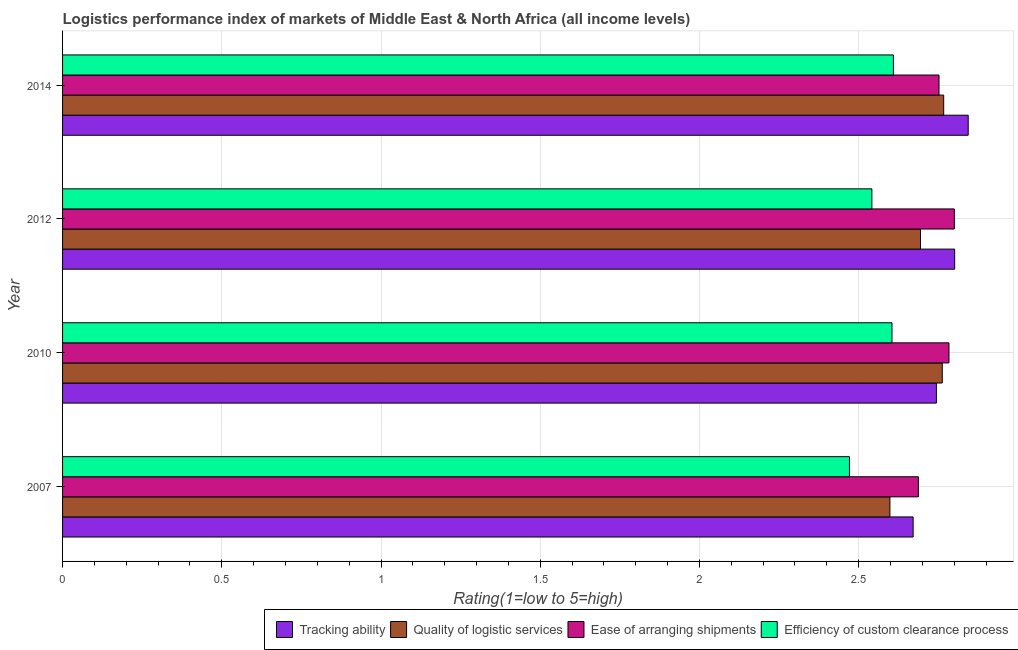How many different coloured bars are there?
Keep it short and to the point. 4. Are the number of bars on each tick of the Y-axis equal?
Ensure brevity in your answer.  Yes. How many bars are there on the 2nd tick from the top?
Your answer should be very brief. 4. What is the label of the 3rd group of bars from the top?
Provide a short and direct response. 2010. What is the lpi rating of efficiency of custom clearance process in 2010?
Offer a very short reply. 2.6. Across all years, what is the maximum lpi rating of tracking ability?
Offer a terse response. 2.84. Across all years, what is the minimum lpi rating of efficiency of custom clearance process?
Your answer should be very brief. 2.47. In which year was the lpi rating of ease of arranging shipments minimum?
Your answer should be compact. 2007. What is the total lpi rating of efficiency of custom clearance process in the graph?
Your response must be concise. 10.23. What is the difference between the lpi rating of quality of logistic services in 2007 and that in 2010?
Make the answer very short. -0.16. What is the difference between the lpi rating of ease of arranging shipments in 2010 and the lpi rating of tracking ability in 2007?
Give a very brief answer. 0.11. What is the average lpi rating of ease of arranging shipments per year?
Make the answer very short. 2.76. In the year 2014, what is the difference between the lpi rating of tracking ability and lpi rating of quality of logistic services?
Your answer should be very brief. 0.08. What is the difference between the highest and the second highest lpi rating of quality of logistic services?
Provide a succinct answer. 0. What is the difference between the highest and the lowest lpi rating of ease of arranging shipments?
Offer a very short reply. 0.11. Is it the case that in every year, the sum of the lpi rating of quality of logistic services and lpi rating of efficiency of custom clearance process is greater than the sum of lpi rating of ease of arranging shipments and lpi rating of tracking ability?
Offer a terse response. No. What does the 3rd bar from the top in 2012 represents?
Your answer should be compact. Quality of logistic services. What does the 3rd bar from the bottom in 2012 represents?
Make the answer very short. Ease of arranging shipments. Is it the case that in every year, the sum of the lpi rating of tracking ability and lpi rating of quality of logistic services is greater than the lpi rating of ease of arranging shipments?
Give a very brief answer. Yes. Are all the bars in the graph horizontal?
Your answer should be compact. Yes. What is the difference between two consecutive major ticks on the X-axis?
Keep it short and to the point. 0.5. Are the values on the major ticks of X-axis written in scientific E-notation?
Your answer should be compact. No. Does the graph contain any zero values?
Ensure brevity in your answer.  No. Does the graph contain grids?
Provide a short and direct response. Yes. How many legend labels are there?
Give a very brief answer. 4. What is the title of the graph?
Your response must be concise. Logistics performance index of markets of Middle East & North Africa (all income levels). Does "Structural Policies" appear as one of the legend labels in the graph?
Make the answer very short. No. What is the label or title of the X-axis?
Your answer should be compact. Rating(1=low to 5=high). What is the Rating(1=low to 5=high) in Tracking ability in 2007?
Offer a terse response. 2.67. What is the Rating(1=low to 5=high) in Quality of logistic services in 2007?
Keep it short and to the point. 2.6. What is the Rating(1=low to 5=high) in Ease of arranging shipments in 2007?
Keep it short and to the point. 2.69. What is the Rating(1=low to 5=high) of Efficiency of custom clearance process in 2007?
Your answer should be compact. 2.47. What is the Rating(1=low to 5=high) in Tracking ability in 2010?
Keep it short and to the point. 2.74. What is the Rating(1=low to 5=high) of Quality of logistic services in 2010?
Your response must be concise. 2.76. What is the Rating(1=low to 5=high) in Ease of arranging shipments in 2010?
Offer a very short reply. 2.78. What is the Rating(1=low to 5=high) of Efficiency of custom clearance process in 2010?
Your response must be concise. 2.6. What is the Rating(1=low to 5=high) in Tracking ability in 2012?
Your answer should be very brief. 2.8. What is the Rating(1=low to 5=high) of Quality of logistic services in 2012?
Make the answer very short. 2.69. What is the Rating(1=low to 5=high) of Ease of arranging shipments in 2012?
Make the answer very short. 2.8. What is the Rating(1=low to 5=high) of Efficiency of custom clearance process in 2012?
Ensure brevity in your answer.  2.54. What is the Rating(1=low to 5=high) of Tracking ability in 2014?
Provide a succinct answer. 2.84. What is the Rating(1=low to 5=high) of Quality of logistic services in 2014?
Provide a short and direct response. 2.77. What is the Rating(1=low to 5=high) of Ease of arranging shipments in 2014?
Your response must be concise. 2.75. What is the Rating(1=low to 5=high) of Efficiency of custom clearance process in 2014?
Ensure brevity in your answer.  2.61. Across all years, what is the maximum Rating(1=low to 5=high) of Tracking ability?
Provide a short and direct response. 2.84. Across all years, what is the maximum Rating(1=low to 5=high) in Quality of logistic services?
Your answer should be very brief. 2.77. Across all years, what is the maximum Rating(1=low to 5=high) in Ease of arranging shipments?
Your answer should be compact. 2.8. Across all years, what is the maximum Rating(1=low to 5=high) in Efficiency of custom clearance process?
Keep it short and to the point. 2.61. Across all years, what is the minimum Rating(1=low to 5=high) of Tracking ability?
Offer a terse response. 2.67. Across all years, what is the minimum Rating(1=low to 5=high) in Quality of logistic services?
Keep it short and to the point. 2.6. Across all years, what is the minimum Rating(1=low to 5=high) of Ease of arranging shipments?
Offer a terse response. 2.69. Across all years, what is the minimum Rating(1=low to 5=high) in Efficiency of custom clearance process?
Provide a succinct answer. 2.47. What is the total Rating(1=low to 5=high) in Tracking ability in the graph?
Your answer should be compact. 11.06. What is the total Rating(1=low to 5=high) in Quality of logistic services in the graph?
Offer a very short reply. 10.82. What is the total Rating(1=low to 5=high) of Ease of arranging shipments in the graph?
Make the answer very short. 11.02. What is the total Rating(1=low to 5=high) in Efficiency of custom clearance process in the graph?
Ensure brevity in your answer.  10.23. What is the difference between the Rating(1=low to 5=high) in Tracking ability in 2007 and that in 2010?
Your response must be concise. -0.07. What is the difference between the Rating(1=low to 5=high) in Quality of logistic services in 2007 and that in 2010?
Give a very brief answer. -0.16. What is the difference between the Rating(1=low to 5=high) in Ease of arranging shipments in 2007 and that in 2010?
Give a very brief answer. -0.1. What is the difference between the Rating(1=low to 5=high) in Efficiency of custom clearance process in 2007 and that in 2010?
Your answer should be compact. -0.13. What is the difference between the Rating(1=low to 5=high) of Tracking ability in 2007 and that in 2012?
Provide a succinct answer. -0.13. What is the difference between the Rating(1=low to 5=high) of Quality of logistic services in 2007 and that in 2012?
Your answer should be very brief. -0.1. What is the difference between the Rating(1=low to 5=high) in Ease of arranging shipments in 2007 and that in 2012?
Your answer should be very brief. -0.11. What is the difference between the Rating(1=low to 5=high) of Efficiency of custom clearance process in 2007 and that in 2012?
Make the answer very short. -0.07. What is the difference between the Rating(1=low to 5=high) of Tracking ability in 2007 and that in 2014?
Provide a succinct answer. -0.17. What is the difference between the Rating(1=low to 5=high) in Quality of logistic services in 2007 and that in 2014?
Your answer should be very brief. -0.17. What is the difference between the Rating(1=low to 5=high) of Ease of arranging shipments in 2007 and that in 2014?
Provide a succinct answer. -0.06. What is the difference between the Rating(1=low to 5=high) of Efficiency of custom clearance process in 2007 and that in 2014?
Ensure brevity in your answer.  -0.14. What is the difference between the Rating(1=low to 5=high) in Tracking ability in 2010 and that in 2012?
Your response must be concise. -0.06. What is the difference between the Rating(1=low to 5=high) of Quality of logistic services in 2010 and that in 2012?
Your answer should be compact. 0.07. What is the difference between the Rating(1=low to 5=high) in Ease of arranging shipments in 2010 and that in 2012?
Keep it short and to the point. -0.02. What is the difference between the Rating(1=low to 5=high) in Efficiency of custom clearance process in 2010 and that in 2012?
Provide a short and direct response. 0.06. What is the difference between the Rating(1=low to 5=high) in Tracking ability in 2010 and that in 2014?
Offer a very short reply. -0.1. What is the difference between the Rating(1=low to 5=high) of Quality of logistic services in 2010 and that in 2014?
Offer a terse response. -0. What is the difference between the Rating(1=low to 5=high) of Ease of arranging shipments in 2010 and that in 2014?
Give a very brief answer. 0.03. What is the difference between the Rating(1=low to 5=high) of Efficiency of custom clearance process in 2010 and that in 2014?
Your response must be concise. -0. What is the difference between the Rating(1=low to 5=high) in Tracking ability in 2012 and that in 2014?
Provide a short and direct response. -0.04. What is the difference between the Rating(1=low to 5=high) of Quality of logistic services in 2012 and that in 2014?
Provide a succinct answer. -0.07. What is the difference between the Rating(1=low to 5=high) in Ease of arranging shipments in 2012 and that in 2014?
Provide a succinct answer. 0.05. What is the difference between the Rating(1=low to 5=high) in Efficiency of custom clearance process in 2012 and that in 2014?
Your response must be concise. -0.07. What is the difference between the Rating(1=low to 5=high) in Tracking ability in 2007 and the Rating(1=low to 5=high) in Quality of logistic services in 2010?
Make the answer very short. -0.09. What is the difference between the Rating(1=low to 5=high) in Tracking ability in 2007 and the Rating(1=low to 5=high) in Ease of arranging shipments in 2010?
Offer a very short reply. -0.11. What is the difference between the Rating(1=low to 5=high) of Tracking ability in 2007 and the Rating(1=low to 5=high) of Efficiency of custom clearance process in 2010?
Keep it short and to the point. 0.07. What is the difference between the Rating(1=low to 5=high) of Quality of logistic services in 2007 and the Rating(1=low to 5=high) of Ease of arranging shipments in 2010?
Provide a short and direct response. -0.19. What is the difference between the Rating(1=low to 5=high) of Quality of logistic services in 2007 and the Rating(1=low to 5=high) of Efficiency of custom clearance process in 2010?
Keep it short and to the point. -0.01. What is the difference between the Rating(1=low to 5=high) of Ease of arranging shipments in 2007 and the Rating(1=low to 5=high) of Efficiency of custom clearance process in 2010?
Keep it short and to the point. 0.08. What is the difference between the Rating(1=low to 5=high) of Tracking ability in 2007 and the Rating(1=low to 5=high) of Quality of logistic services in 2012?
Ensure brevity in your answer.  -0.02. What is the difference between the Rating(1=low to 5=high) in Tracking ability in 2007 and the Rating(1=low to 5=high) in Ease of arranging shipments in 2012?
Your answer should be compact. -0.13. What is the difference between the Rating(1=low to 5=high) of Tracking ability in 2007 and the Rating(1=low to 5=high) of Efficiency of custom clearance process in 2012?
Offer a very short reply. 0.13. What is the difference between the Rating(1=low to 5=high) in Quality of logistic services in 2007 and the Rating(1=low to 5=high) in Ease of arranging shipments in 2012?
Provide a short and direct response. -0.2. What is the difference between the Rating(1=low to 5=high) of Quality of logistic services in 2007 and the Rating(1=low to 5=high) of Efficiency of custom clearance process in 2012?
Provide a succinct answer. 0.06. What is the difference between the Rating(1=low to 5=high) in Ease of arranging shipments in 2007 and the Rating(1=low to 5=high) in Efficiency of custom clearance process in 2012?
Offer a very short reply. 0.15. What is the difference between the Rating(1=low to 5=high) of Tracking ability in 2007 and the Rating(1=low to 5=high) of Quality of logistic services in 2014?
Make the answer very short. -0.1. What is the difference between the Rating(1=low to 5=high) of Tracking ability in 2007 and the Rating(1=low to 5=high) of Ease of arranging shipments in 2014?
Offer a terse response. -0.08. What is the difference between the Rating(1=low to 5=high) in Tracking ability in 2007 and the Rating(1=low to 5=high) in Efficiency of custom clearance process in 2014?
Your answer should be compact. 0.06. What is the difference between the Rating(1=low to 5=high) in Quality of logistic services in 2007 and the Rating(1=low to 5=high) in Ease of arranging shipments in 2014?
Ensure brevity in your answer.  -0.15. What is the difference between the Rating(1=low to 5=high) of Quality of logistic services in 2007 and the Rating(1=low to 5=high) of Efficiency of custom clearance process in 2014?
Your answer should be very brief. -0.01. What is the difference between the Rating(1=low to 5=high) of Ease of arranging shipments in 2007 and the Rating(1=low to 5=high) of Efficiency of custom clearance process in 2014?
Offer a very short reply. 0.08. What is the difference between the Rating(1=low to 5=high) of Tracking ability in 2010 and the Rating(1=low to 5=high) of Quality of logistic services in 2012?
Keep it short and to the point. 0.05. What is the difference between the Rating(1=low to 5=high) in Tracking ability in 2010 and the Rating(1=low to 5=high) in Ease of arranging shipments in 2012?
Offer a very short reply. -0.06. What is the difference between the Rating(1=low to 5=high) of Tracking ability in 2010 and the Rating(1=low to 5=high) of Efficiency of custom clearance process in 2012?
Offer a very short reply. 0.2. What is the difference between the Rating(1=low to 5=high) in Quality of logistic services in 2010 and the Rating(1=low to 5=high) in Ease of arranging shipments in 2012?
Ensure brevity in your answer.  -0.04. What is the difference between the Rating(1=low to 5=high) of Quality of logistic services in 2010 and the Rating(1=low to 5=high) of Efficiency of custom clearance process in 2012?
Provide a succinct answer. 0.22. What is the difference between the Rating(1=low to 5=high) in Ease of arranging shipments in 2010 and the Rating(1=low to 5=high) in Efficiency of custom clearance process in 2012?
Your answer should be very brief. 0.24. What is the difference between the Rating(1=low to 5=high) in Tracking ability in 2010 and the Rating(1=low to 5=high) in Quality of logistic services in 2014?
Ensure brevity in your answer.  -0.02. What is the difference between the Rating(1=low to 5=high) in Tracking ability in 2010 and the Rating(1=low to 5=high) in Ease of arranging shipments in 2014?
Your answer should be very brief. -0.01. What is the difference between the Rating(1=low to 5=high) of Tracking ability in 2010 and the Rating(1=low to 5=high) of Efficiency of custom clearance process in 2014?
Keep it short and to the point. 0.14. What is the difference between the Rating(1=low to 5=high) of Quality of logistic services in 2010 and the Rating(1=low to 5=high) of Ease of arranging shipments in 2014?
Ensure brevity in your answer.  0.01. What is the difference between the Rating(1=low to 5=high) of Quality of logistic services in 2010 and the Rating(1=low to 5=high) of Efficiency of custom clearance process in 2014?
Offer a very short reply. 0.15. What is the difference between the Rating(1=low to 5=high) of Ease of arranging shipments in 2010 and the Rating(1=low to 5=high) of Efficiency of custom clearance process in 2014?
Ensure brevity in your answer.  0.17. What is the difference between the Rating(1=low to 5=high) in Tracking ability in 2012 and the Rating(1=low to 5=high) in Quality of logistic services in 2014?
Your answer should be very brief. 0.03. What is the difference between the Rating(1=low to 5=high) of Tracking ability in 2012 and the Rating(1=low to 5=high) of Ease of arranging shipments in 2014?
Your response must be concise. 0.05. What is the difference between the Rating(1=low to 5=high) in Tracking ability in 2012 and the Rating(1=low to 5=high) in Efficiency of custom clearance process in 2014?
Offer a very short reply. 0.19. What is the difference between the Rating(1=low to 5=high) in Quality of logistic services in 2012 and the Rating(1=low to 5=high) in Ease of arranging shipments in 2014?
Keep it short and to the point. -0.06. What is the difference between the Rating(1=low to 5=high) of Quality of logistic services in 2012 and the Rating(1=low to 5=high) of Efficiency of custom clearance process in 2014?
Offer a very short reply. 0.09. What is the difference between the Rating(1=low to 5=high) of Ease of arranging shipments in 2012 and the Rating(1=low to 5=high) of Efficiency of custom clearance process in 2014?
Make the answer very short. 0.19. What is the average Rating(1=low to 5=high) of Tracking ability per year?
Keep it short and to the point. 2.77. What is the average Rating(1=low to 5=high) of Quality of logistic services per year?
Give a very brief answer. 2.71. What is the average Rating(1=low to 5=high) in Ease of arranging shipments per year?
Your answer should be compact. 2.76. What is the average Rating(1=low to 5=high) of Efficiency of custom clearance process per year?
Your response must be concise. 2.56. In the year 2007, what is the difference between the Rating(1=low to 5=high) in Tracking ability and Rating(1=low to 5=high) in Quality of logistic services?
Ensure brevity in your answer.  0.07. In the year 2007, what is the difference between the Rating(1=low to 5=high) of Tracking ability and Rating(1=low to 5=high) of Ease of arranging shipments?
Provide a succinct answer. -0.02. In the year 2007, what is the difference between the Rating(1=low to 5=high) of Quality of logistic services and Rating(1=low to 5=high) of Ease of arranging shipments?
Make the answer very short. -0.09. In the year 2007, what is the difference between the Rating(1=low to 5=high) in Quality of logistic services and Rating(1=low to 5=high) in Efficiency of custom clearance process?
Your response must be concise. 0.13. In the year 2007, what is the difference between the Rating(1=low to 5=high) of Ease of arranging shipments and Rating(1=low to 5=high) of Efficiency of custom clearance process?
Ensure brevity in your answer.  0.22. In the year 2010, what is the difference between the Rating(1=low to 5=high) of Tracking ability and Rating(1=low to 5=high) of Quality of logistic services?
Provide a succinct answer. -0.02. In the year 2010, what is the difference between the Rating(1=low to 5=high) in Tracking ability and Rating(1=low to 5=high) in Ease of arranging shipments?
Provide a succinct answer. -0.04. In the year 2010, what is the difference between the Rating(1=low to 5=high) in Tracking ability and Rating(1=low to 5=high) in Efficiency of custom clearance process?
Provide a short and direct response. 0.14. In the year 2010, what is the difference between the Rating(1=low to 5=high) of Quality of logistic services and Rating(1=low to 5=high) of Ease of arranging shipments?
Give a very brief answer. -0.02. In the year 2010, what is the difference between the Rating(1=low to 5=high) of Quality of logistic services and Rating(1=low to 5=high) of Efficiency of custom clearance process?
Give a very brief answer. 0.16. In the year 2010, what is the difference between the Rating(1=low to 5=high) of Ease of arranging shipments and Rating(1=low to 5=high) of Efficiency of custom clearance process?
Make the answer very short. 0.18. In the year 2012, what is the difference between the Rating(1=low to 5=high) in Tracking ability and Rating(1=low to 5=high) in Quality of logistic services?
Provide a succinct answer. 0.11. In the year 2012, what is the difference between the Rating(1=low to 5=high) in Tracking ability and Rating(1=low to 5=high) in Ease of arranging shipments?
Your response must be concise. 0. In the year 2012, what is the difference between the Rating(1=low to 5=high) in Tracking ability and Rating(1=low to 5=high) in Efficiency of custom clearance process?
Ensure brevity in your answer.  0.26. In the year 2012, what is the difference between the Rating(1=low to 5=high) of Quality of logistic services and Rating(1=low to 5=high) of Ease of arranging shipments?
Offer a terse response. -0.11. In the year 2012, what is the difference between the Rating(1=low to 5=high) of Quality of logistic services and Rating(1=low to 5=high) of Efficiency of custom clearance process?
Your response must be concise. 0.15. In the year 2012, what is the difference between the Rating(1=low to 5=high) of Ease of arranging shipments and Rating(1=low to 5=high) of Efficiency of custom clearance process?
Offer a terse response. 0.26. In the year 2014, what is the difference between the Rating(1=low to 5=high) of Tracking ability and Rating(1=low to 5=high) of Quality of logistic services?
Offer a very short reply. 0.08. In the year 2014, what is the difference between the Rating(1=low to 5=high) in Tracking ability and Rating(1=low to 5=high) in Ease of arranging shipments?
Ensure brevity in your answer.  0.09. In the year 2014, what is the difference between the Rating(1=low to 5=high) of Tracking ability and Rating(1=low to 5=high) of Efficiency of custom clearance process?
Your answer should be compact. 0.23. In the year 2014, what is the difference between the Rating(1=low to 5=high) of Quality of logistic services and Rating(1=low to 5=high) of Ease of arranging shipments?
Your response must be concise. 0.01. In the year 2014, what is the difference between the Rating(1=low to 5=high) of Quality of logistic services and Rating(1=low to 5=high) of Efficiency of custom clearance process?
Offer a very short reply. 0.16. In the year 2014, what is the difference between the Rating(1=low to 5=high) in Ease of arranging shipments and Rating(1=low to 5=high) in Efficiency of custom clearance process?
Ensure brevity in your answer.  0.14. What is the ratio of the Rating(1=low to 5=high) in Tracking ability in 2007 to that in 2010?
Provide a short and direct response. 0.97. What is the ratio of the Rating(1=low to 5=high) of Quality of logistic services in 2007 to that in 2010?
Make the answer very short. 0.94. What is the ratio of the Rating(1=low to 5=high) of Ease of arranging shipments in 2007 to that in 2010?
Your answer should be compact. 0.97. What is the ratio of the Rating(1=low to 5=high) of Efficiency of custom clearance process in 2007 to that in 2010?
Offer a very short reply. 0.95. What is the ratio of the Rating(1=low to 5=high) in Tracking ability in 2007 to that in 2012?
Provide a succinct answer. 0.95. What is the ratio of the Rating(1=low to 5=high) in Quality of logistic services in 2007 to that in 2012?
Your answer should be compact. 0.96. What is the ratio of the Rating(1=low to 5=high) in Ease of arranging shipments in 2007 to that in 2012?
Keep it short and to the point. 0.96. What is the ratio of the Rating(1=low to 5=high) of Efficiency of custom clearance process in 2007 to that in 2012?
Keep it short and to the point. 0.97. What is the ratio of the Rating(1=low to 5=high) in Tracking ability in 2007 to that in 2014?
Give a very brief answer. 0.94. What is the ratio of the Rating(1=low to 5=high) of Quality of logistic services in 2007 to that in 2014?
Offer a very short reply. 0.94. What is the ratio of the Rating(1=low to 5=high) in Ease of arranging shipments in 2007 to that in 2014?
Keep it short and to the point. 0.98. What is the ratio of the Rating(1=low to 5=high) in Efficiency of custom clearance process in 2007 to that in 2014?
Offer a very short reply. 0.95. What is the ratio of the Rating(1=low to 5=high) of Tracking ability in 2010 to that in 2012?
Make the answer very short. 0.98. What is the ratio of the Rating(1=low to 5=high) of Quality of logistic services in 2010 to that in 2012?
Give a very brief answer. 1.03. What is the ratio of the Rating(1=low to 5=high) in Efficiency of custom clearance process in 2010 to that in 2012?
Your answer should be compact. 1.02. What is the ratio of the Rating(1=low to 5=high) of Tracking ability in 2010 to that in 2014?
Provide a succinct answer. 0.96. What is the ratio of the Rating(1=low to 5=high) in Ease of arranging shipments in 2010 to that in 2014?
Your answer should be compact. 1.01. What is the ratio of the Rating(1=low to 5=high) in Efficiency of custom clearance process in 2010 to that in 2014?
Your response must be concise. 1. What is the ratio of the Rating(1=low to 5=high) in Tracking ability in 2012 to that in 2014?
Keep it short and to the point. 0.99. What is the ratio of the Rating(1=low to 5=high) in Quality of logistic services in 2012 to that in 2014?
Keep it short and to the point. 0.97. What is the ratio of the Rating(1=low to 5=high) of Ease of arranging shipments in 2012 to that in 2014?
Give a very brief answer. 1.02. What is the ratio of the Rating(1=low to 5=high) of Efficiency of custom clearance process in 2012 to that in 2014?
Make the answer very short. 0.97. What is the difference between the highest and the second highest Rating(1=low to 5=high) in Tracking ability?
Your answer should be compact. 0.04. What is the difference between the highest and the second highest Rating(1=low to 5=high) of Quality of logistic services?
Keep it short and to the point. 0. What is the difference between the highest and the second highest Rating(1=low to 5=high) of Ease of arranging shipments?
Provide a succinct answer. 0.02. What is the difference between the highest and the second highest Rating(1=low to 5=high) of Efficiency of custom clearance process?
Your answer should be very brief. 0. What is the difference between the highest and the lowest Rating(1=low to 5=high) in Tracking ability?
Your response must be concise. 0.17. What is the difference between the highest and the lowest Rating(1=low to 5=high) in Quality of logistic services?
Provide a succinct answer. 0.17. What is the difference between the highest and the lowest Rating(1=low to 5=high) in Ease of arranging shipments?
Your answer should be very brief. 0.11. What is the difference between the highest and the lowest Rating(1=low to 5=high) in Efficiency of custom clearance process?
Provide a succinct answer. 0.14. 